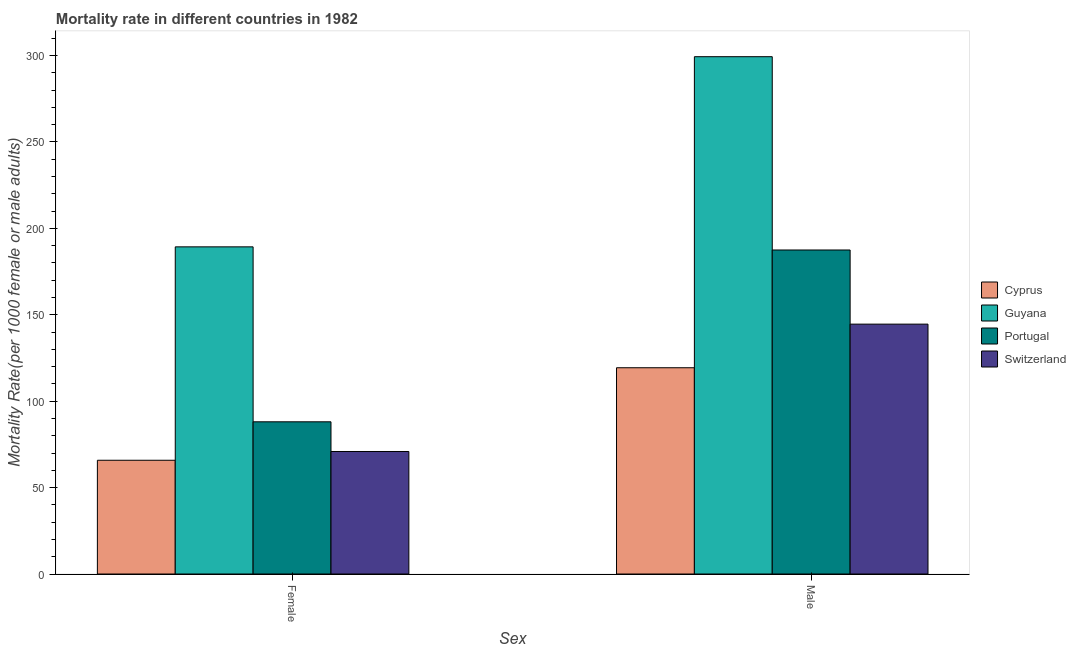How many different coloured bars are there?
Your answer should be compact. 4. How many bars are there on the 2nd tick from the left?
Your answer should be very brief. 4. What is the label of the 2nd group of bars from the left?
Provide a succinct answer. Male. What is the female mortality rate in Portugal?
Provide a succinct answer. 88.08. Across all countries, what is the maximum female mortality rate?
Make the answer very short. 189.31. Across all countries, what is the minimum female mortality rate?
Offer a terse response. 65.82. In which country was the male mortality rate maximum?
Ensure brevity in your answer.  Guyana. In which country was the female mortality rate minimum?
Your response must be concise. Cyprus. What is the total male mortality rate in the graph?
Offer a terse response. 750.8. What is the difference between the female mortality rate in Guyana and that in Switzerland?
Provide a succinct answer. 118.42. What is the difference between the male mortality rate in Cyprus and the female mortality rate in Portugal?
Offer a very short reply. 31.28. What is the average male mortality rate per country?
Give a very brief answer. 187.7. What is the difference between the female mortality rate and male mortality rate in Cyprus?
Make the answer very short. -53.53. In how many countries, is the female mortality rate greater than 190 ?
Make the answer very short. 0. What is the ratio of the male mortality rate in Portugal to that in Guyana?
Your response must be concise. 0.63. Is the female mortality rate in Portugal less than that in Guyana?
Ensure brevity in your answer.  Yes. What does the 1st bar from the left in Female represents?
Provide a succinct answer. Cyprus. What does the 3rd bar from the right in Male represents?
Your response must be concise. Guyana. Are all the bars in the graph horizontal?
Make the answer very short. No. How many countries are there in the graph?
Keep it short and to the point. 4. What is the difference between two consecutive major ticks on the Y-axis?
Provide a succinct answer. 50. Does the graph contain grids?
Your answer should be very brief. No. How many legend labels are there?
Offer a very short reply. 4. What is the title of the graph?
Provide a short and direct response. Mortality rate in different countries in 1982. Does "Guinea" appear as one of the legend labels in the graph?
Provide a short and direct response. No. What is the label or title of the X-axis?
Your response must be concise. Sex. What is the label or title of the Y-axis?
Offer a very short reply. Mortality Rate(per 1000 female or male adults). What is the Mortality Rate(per 1000 female or male adults) of Cyprus in Female?
Provide a short and direct response. 65.82. What is the Mortality Rate(per 1000 female or male adults) in Guyana in Female?
Give a very brief answer. 189.31. What is the Mortality Rate(per 1000 female or male adults) of Portugal in Female?
Provide a succinct answer. 88.08. What is the Mortality Rate(per 1000 female or male adults) of Switzerland in Female?
Offer a terse response. 70.89. What is the Mortality Rate(per 1000 female or male adults) of Cyprus in Male?
Provide a succinct answer. 119.36. What is the Mortality Rate(per 1000 female or male adults) of Guyana in Male?
Your response must be concise. 299.36. What is the Mortality Rate(per 1000 female or male adults) of Portugal in Male?
Provide a short and direct response. 187.5. What is the Mortality Rate(per 1000 female or male adults) in Switzerland in Male?
Provide a succinct answer. 144.59. Across all Sex, what is the maximum Mortality Rate(per 1000 female or male adults) of Cyprus?
Offer a terse response. 119.36. Across all Sex, what is the maximum Mortality Rate(per 1000 female or male adults) in Guyana?
Make the answer very short. 299.36. Across all Sex, what is the maximum Mortality Rate(per 1000 female or male adults) in Portugal?
Ensure brevity in your answer.  187.5. Across all Sex, what is the maximum Mortality Rate(per 1000 female or male adults) in Switzerland?
Make the answer very short. 144.59. Across all Sex, what is the minimum Mortality Rate(per 1000 female or male adults) in Cyprus?
Your answer should be very brief. 65.82. Across all Sex, what is the minimum Mortality Rate(per 1000 female or male adults) in Guyana?
Provide a succinct answer. 189.31. Across all Sex, what is the minimum Mortality Rate(per 1000 female or male adults) in Portugal?
Provide a succinct answer. 88.08. Across all Sex, what is the minimum Mortality Rate(per 1000 female or male adults) of Switzerland?
Offer a very short reply. 70.89. What is the total Mortality Rate(per 1000 female or male adults) of Cyprus in the graph?
Keep it short and to the point. 185.18. What is the total Mortality Rate(per 1000 female or male adults) of Guyana in the graph?
Provide a succinct answer. 488.67. What is the total Mortality Rate(per 1000 female or male adults) in Portugal in the graph?
Your response must be concise. 275.58. What is the total Mortality Rate(per 1000 female or male adults) of Switzerland in the graph?
Offer a very short reply. 215.49. What is the difference between the Mortality Rate(per 1000 female or male adults) in Cyprus in Female and that in Male?
Offer a very short reply. -53.53. What is the difference between the Mortality Rate(per 1000 female or male adults) of Guyana in Female and that in Male?
Provide a succinct answer. -110.04. What is the difference between the Mortality Rate(per 1000 female or male adults) in Portugal in Female and that in Male?
Give a very brief answer. -99.42. What is the difference between the Mortality Rate(per 1000 female or male adults) of Switzerland in Female and that in Male?
Your response must be concise. -73.7. What is the difference between the Mortality Rate(per 1000 female or male adults) in Cyprus in Female and the Mortality Rate(per 1000 female or male adults) in Guyana in Male?
Your answer should be very brief. -233.53. What is the difference between the Mortality Rate(per 1000 female or male adults) in Cyprus in Female and the Mortality Rate(per 1000 female or male adults) in Portugal in Male?
Provide a short and direct response. -121.67. What is the difference between the Mortality Rate(per 1000 female or male adults) of Cyprus in Female and the Mortality Rate(per 1000 female or male adults) of Switzerland in Male?
Make the answer very short. -78.77. What is the difference between the Mortality Rate(per 1000 female or male adults) of Guyana in Female and the Mortality Rate(per 1000 female or male adults) of Portugal in Male?
Your answer should be very brief. 1.82. What is the difference between the Mortality Rate(per 1000 female or male adults) in Guyana in Female and the Mortality Rate(per 1000 female or male adults) in Switzerland in Male?
Your answer should be very brief. 44.72. What is the difference between the Mortality Rate(per 1000 female or male adults) of Portugal in Female and the Mortality Rate(per 1000 female or male adults) of Switzerland in Male?
Your response must be concise. -56.52. What is the average Mortality Rate(per 1000 female or male adults) of Cyprus per Sex?
Make the answer very short. 92.59. What is the average Mortality Rate(per 1000 female or male adults) in Guyana per Sex?
Ensure brevity in your answer.  244.34. What is the average Mortality Rate(per 1000 female or male adults) in Portugal per Sex?
Make the answer very short. 137.79. What is the average Mortality Rate(per 1000 female or male adults) of Switzerland per Sex?
Keep it short and to the point. 107.74. What is the difference between the Mortality Rate(per 1000 female or male adults) in Cyprus and Mortality Rate(per 1000 female or male adults) in Guyana in Female?
Your answer should be very brief. -123.49. What is the difference between the Mortality Rate(per 1000 female or male adults) in Cyprus and Mortality Rate(per 1000 female or male adults) in Portugal in Female?
Your answer should be compact. -22.25. What is the difference between the Mortality Rate(per 1000 female or male adults) in Cyprus and Mortality Rate(per 1000 female or male adults) in Switzerland in Female?
Make the answer very short. -5.07. What is the difference between the Mortality Rate(per 1000 female or male adults) in Guyana and Mortality Rate(per 1000 female or male adults) in Portugal in Female?
Your response must be concise. 101.24. What is the difference between the Mortality Rate(per 1000 female or male adults) of Guyana and Mortality Rate(per 1000 female or male adults) of Switzerland in Female?
Offer a terse response. 118.42. What is the difference between the Mortality Rate(per 1000 female or male adults) of Portugal and Mortality Rate(per 1000 female or male adults) of Switzerland in Female?
Offer a very short reply. 17.19. What is the difference between the Mortality Rate(per 1000 female or male adults) in Cyprus and Mortality Rate(per 1000 female or male adults) in Guyana in Male?
Make the answer very short. -180. What is the difference between the Mortality Rate(per 1000 female or male adults) of Cyprus and Mortality Rate(per 1000 female or male adults) of Portugal in Male?
Give a very brief answer. -68.14. What is the difference between the Mortality Rate(per 1000 female or male adults) in Cyprus and Mortality Rate(per 1000 female or male adults) in Switzerland in Male?
Offer a terse response. -25.24. What is the difference between the Mortality Rate(per 1000 female or male adults) in Guyana and Mortality Rate(per 1000 female or male adults) in Portugal in Male?
Ensure brevity in your answer.  111.86. What is the difference between the Mortality Rate(per 1000 female or male adults) of Guyana and Mortality Rate(per 1000 female or male adults) of Switzerland in Male?
Ensure brevity in your answer.  154.76. What is the difference between the Mortality Rate(per 1000 female or male adults) in Portugal and Mortality Rate(per 1000 female or male adults) in Switzerland in Male?
Give a very brief answer. 42.91. What is the ratio of the Mortality Rate(per 1000 female or male adults) in Cyprus in Female to that in Male?
Make the answer very short. 0.55. What is the ratio of the Mortality Rate(per 1000 female or male adults) in Guyana in Female to that in Male?
Your response must be concise. 0.63. What is the ratio of the Mortality Rate(per 1000 female or male adults) in Portugal in Female to that in Male?
Keep it short and to the point. 0.47. What is the ratio of the Mortality Rate(per 1000 female or male adults) in Switzerland in Female to that in Male?
Offer a very short reply. 0.49. What is the difference between the highest and the second highest Mortality Rate(per 1000 female or male adults) in Cyprus?
Your answer should be very brief. 53.53. What is the difference between the highest and the second highest Mortality Rate(per 1000 female or male adults) in Guyana?
Offer a very short reply. 110.04. What is the difference between the highest and the second highest Mortality Rate(per 1000 female or male adults) in Portugal?
Make the answer very short. 99.42. What is the difference between the highest and the second highest Mortality Rate(per 1000 female or male adults) in Switzerland?
Keep it short and to the point. 73.7. What is the difference between the highest and the lowest Mortality Rate(per 1000 female or male adults) in Cyprus?
Provide a short and direct response. 53.53. What is the difference between the highest and the lowest Mortality Rate(per 1000 female or male adults) of Guyana?
Keep it short and to the point. 110.04. What is the difference between the highest and the lowest Mortality Rate(per 1000 female or male adults) of Portugal?
Offer a very short reply. 99.42. What is the difference between the highest and the lowest Mortality Rate(per 1000 female or male adults) in Switzerland?
Your response must be concise. 73.7. 